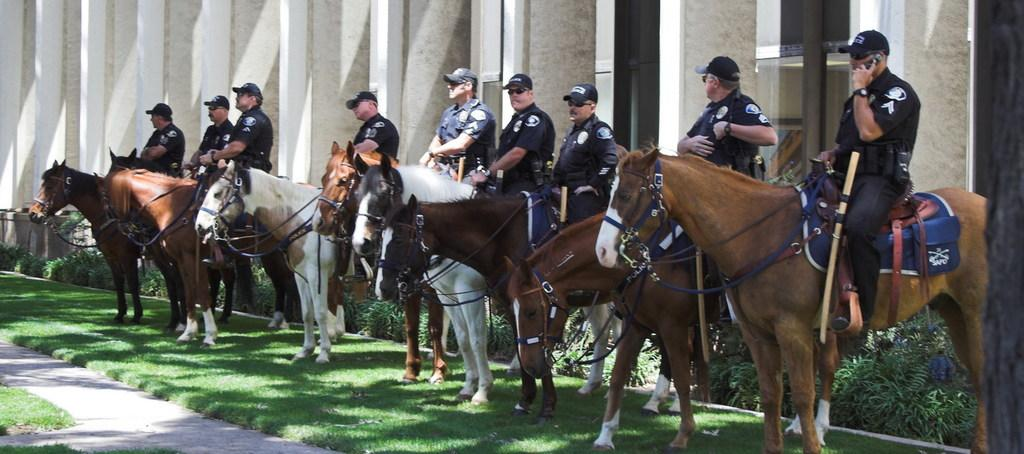What are the people in the image doing? The people in the image are sitting on horses. What type of vegetation can be seen in the image? There are plants and grass in the image. What structure is visible in the image? There is a building in the image. What object can be seen in the image that is not related to the people or the horses? There is a rod in the image. Can you describe the wings of the birds flying over the waves in the image? There are no birds or waves present in the image; it features people sitting on horses, plants, grass, a building, and a rod. 